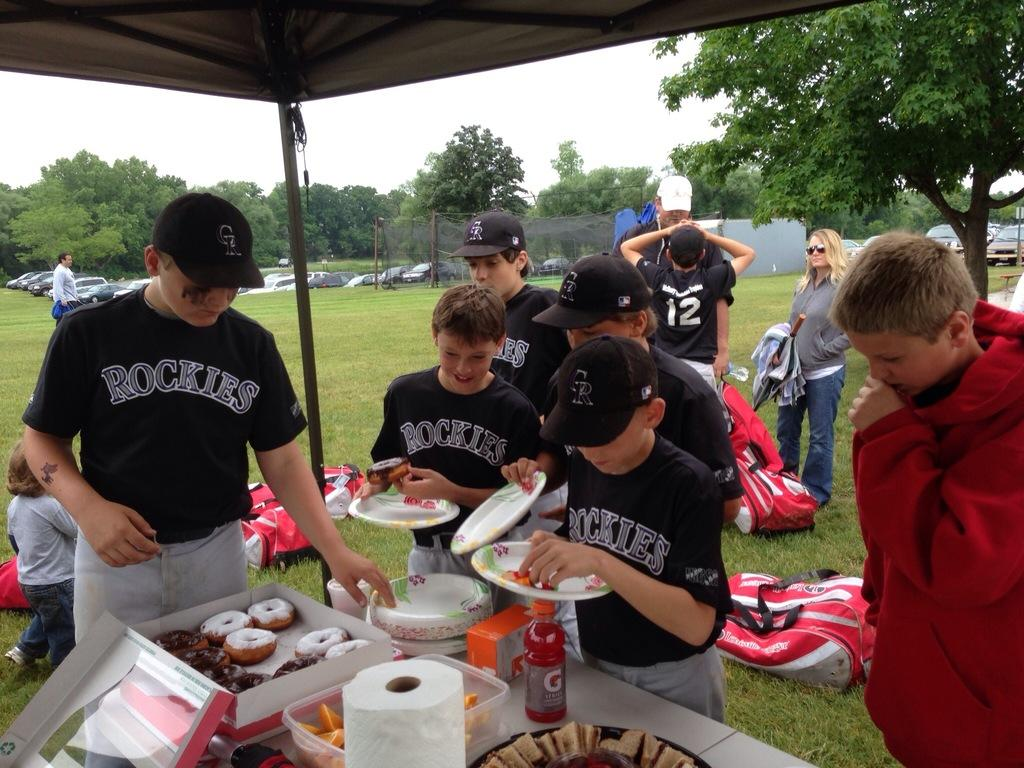Provide a one-sentence caption for the provided image. Young boys in Rockies baseball uniforms pick up donuts at a table. 